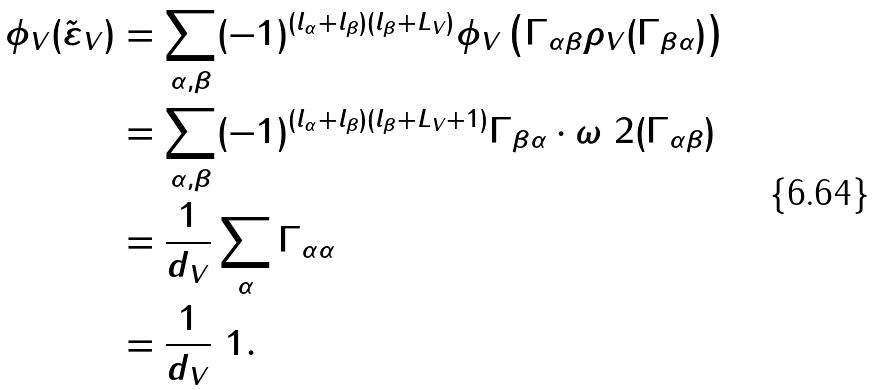<formula> <loc_0><loc_0><loc_500><loc_500>\phi _ { V } ( \tilde { \varepsilon } _ { V } ) & = \sum _ { \alpha , \beta } ( - 1 ) ^ { ( l _ { \alpha } + l _ { \beta } ) ( l _ { \beta } + L _ { V } ) } \phi _ { V } \left ( \Gamma _ { \alpha \beta } \rho _ { V } ( \Gamma _ { \beta \alpha } ) \right ) \\ & = \sum _ { \alpha , \beta } ( - 1 ) ^ { ( l _ { \alpha } + l _ { \beta } ) ( l _ { \beta } + L _ { V } + 1 ) } \Gamma _ { \beta \alpha } \cdot \omega _ { \ } 2 ( \Gamma _ { \alpha \beta } ) \\ & = \frac { 1 } { d _ { V } } \sum _ { \alpha } \Gamma _ { \alpha \alpha } \\ & = \frac { 1 } { d _ { V } } \ 1 .</formula> 